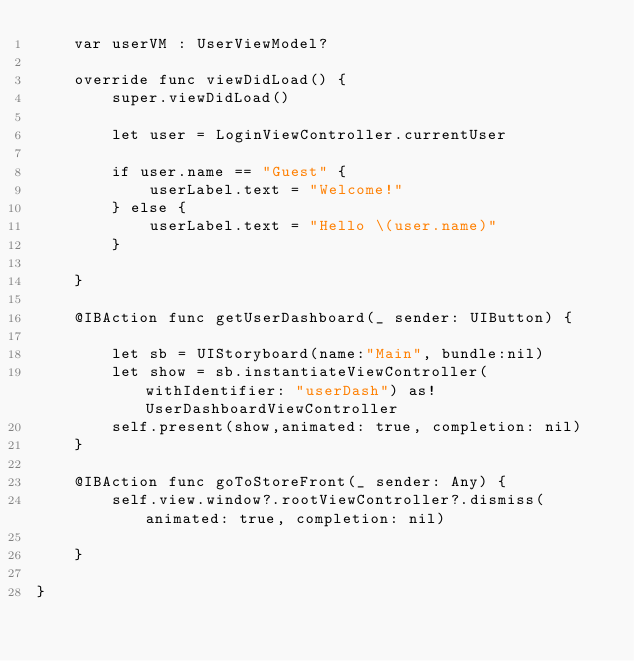<code> <loc_0><loc_0><loc_500><loc_500><_Swift_>    var userVM : UserViewModel?

    override func viewDidLoad() {
        super.viewDidLoad()
        
        let user = LoginViewController.currentUser
        
        if user.name == "Guest" {
            userLabel.text = "Welcome!"
        } else {
            userLabel.text = "Hello \(user.name)"
        }
        
    }
   
    @IBAction func getUserDashboard(_ sender: UIButton) {
        
        let sb = UIStoryboard(name:"Main", bundle:nil)
        let show = sb.instantiateViewController(withIdentifier: "userDash") as! UserDashboardViewController
        self.present(show,animated: true, completion: nil)
    }

    @IBAction func goToStoreFront(_ sender: Any) {
        self.view.window?.rootViewController?.dismiss(animated: true, completion: nil)
        
    }
    
}
</code> 